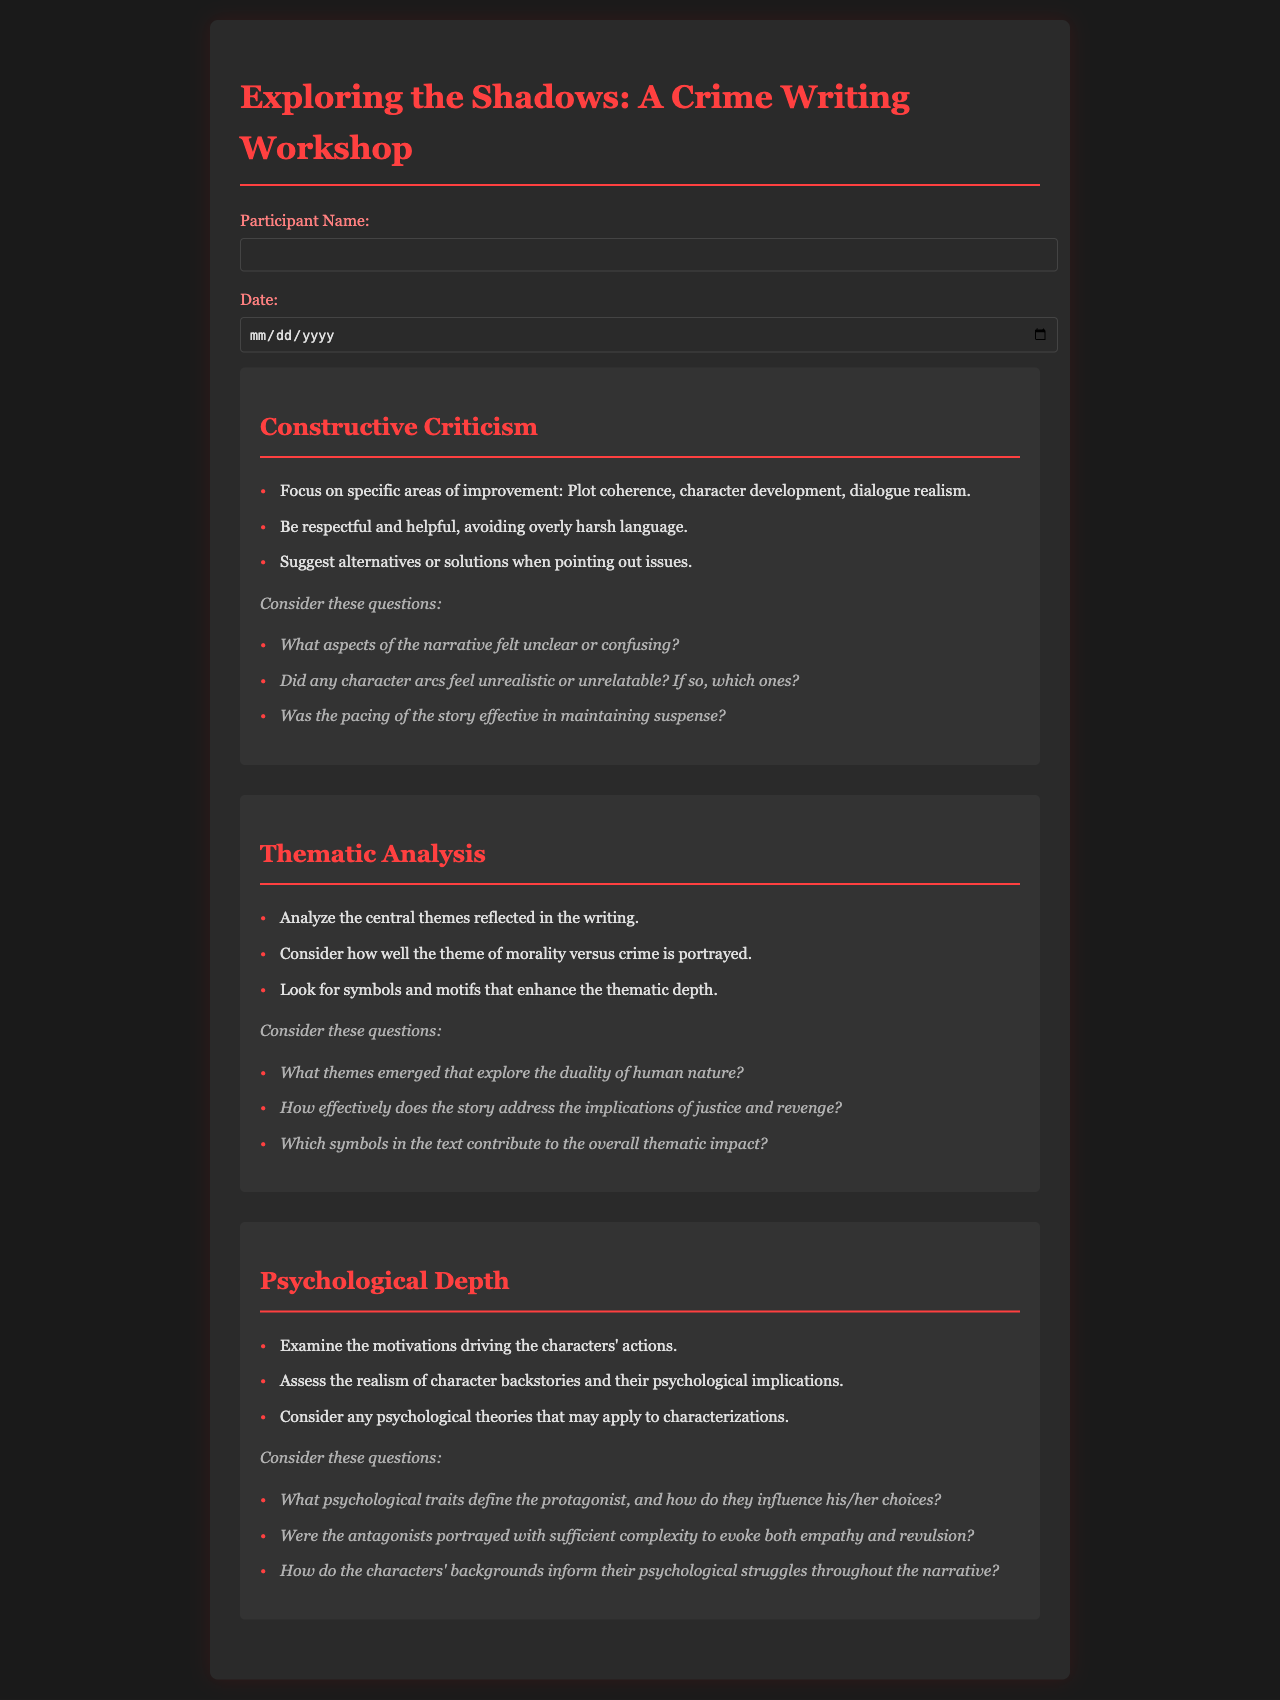What is the title of the workshop? The title of the workshop is prominently displayed in the header of the document.
Answer: Exploring the Shadows: A Crime Writing Workshop Who is encouraged to give constructive criticism? The document highlights that critiques should be focused, respectful, and helpful for participants.
Answer: Participants What is one of the specific aspects of criticism listed? The document enumerates specific areas for constructive feedback on the writing workshop.
Answer: Plot coherence What theme is particularly analyzed in relation to morality? The document specifies a central theme regarding the moral dilemmas presented in the narratives.
Answer: Morality versus crime What psychological aspect is suggested to examine in the characters? The document encourages examining motivative factors behind characters' decisions.
Answer: Motivations What kind of traits should define the protagonist? This element is discussed under the psychological depth section regarding character development.
Answer: Psychological traits How many sections are there in the feedback form? The content structure of the document indicates a specific number of distinct sections categorized as main topics.
Answer: Three Which color is used for the headings in the document? The document designates a particular color to headings, enhancing their visibility against the background.
Answer: Red What is required from participants when giving criticism? The workshop feedback process emphasizes that suggestions should be constructive and based on helpful perspectives.
Answer: Respectful and helpful 